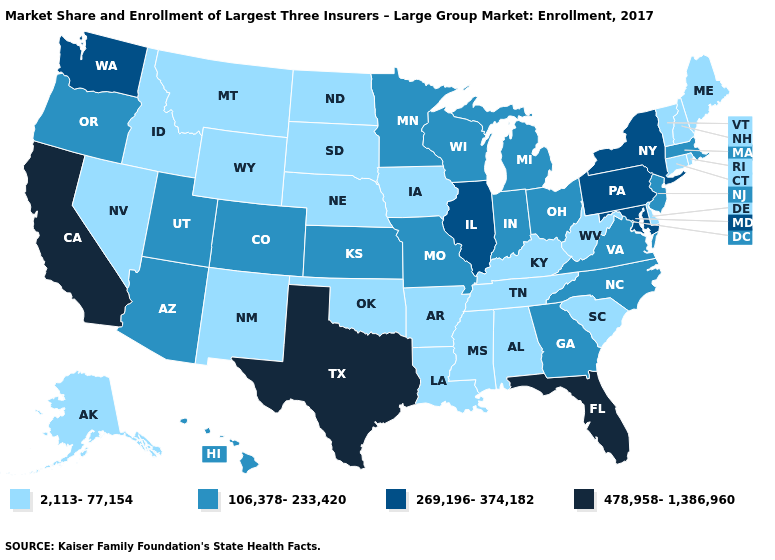What is the value of Wyoming?
Write a very short answer. 2,113-77,154. Name the states that have a value in the range 106,378-233,420?
Concise answer only. Arizona, Colorado, Georgia, Hawaii, Indiana, Kansas, Massachusetts, Michigan, Minnesota, Missouri, New Jersey, North Carolina, Ohio, Oregon, Utah, Virginia, Wisconsin. What is the value of Arkansas?
Short answer required. 2,113-77,154. What is the value of Louisiana?
Be succinct. 2,113-77,154. Does Texas have the highest value in the USA?
Be succinct. Yes. What is the lowest value in states that border Georgia?
Keep it brief. 2,113-77,154. What is the highest value in states that border Illinois?
Write a very short answer. 106,378-233,420. What is the value of New Mexico?
Quick response, please. 2,113-77,154. What is the value of Vermont?
Give a very brief answer. 2,113-77,154. Is the legend a continuous bar?
Write a very short answer. No. Does Oregon have a higher value than New Jersey?
Quick response, please. No. Does Rhode Island have the same value as Michigan?
Short answer required. No. Among the states that border Wyoming , which have the highest value?
Short answer required. Colorado, Utah. Which states hav the highest value in the Northeast?
Give a very brief answer. New York, Pennsylvania. What is the lowest value in the Northeast?
Give a very brief answer. 2,113-77,154. 